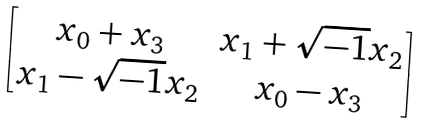<formula> <loc_0><loc_0><loc_500><loc_500>\begin{bmatrix} x _ { 0 } + x _ { 3 } & x _ { 1 } + \sqrt { - 1 } x _ { 2 } \\ x _ { 1 } - \sqrt { - 1 } x _ { 2 } & x _ { 0 } - x _ { 3 } \end{bmatrix}</formula> 